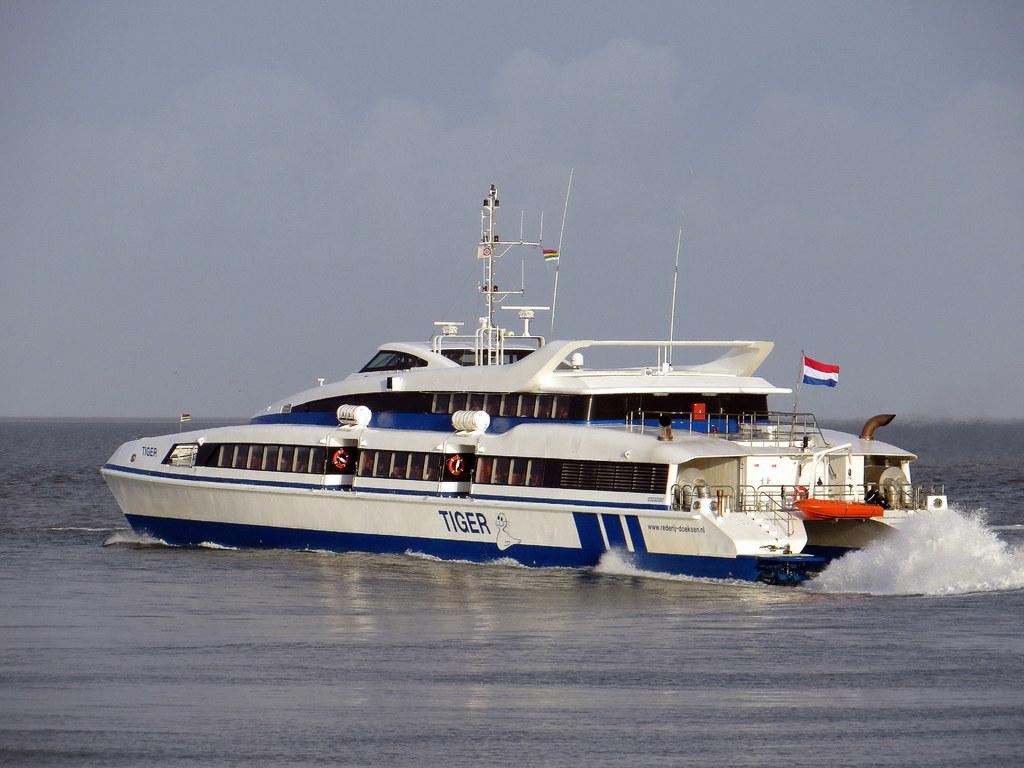What is the main subject of the image? The main subject of the image is a ship. What is the ship doing in the image? The ship is sailing on the water. How many floors does the ship have? The ship has two floors. Is there any indication of the ship's nationality or affiliation in the image? Yes, there is a flag flying on the second floor of the ship. What type of memory is stored in the canvas on the ship? There is no canvas present in the image, and therefore no memory can be stored on it. 